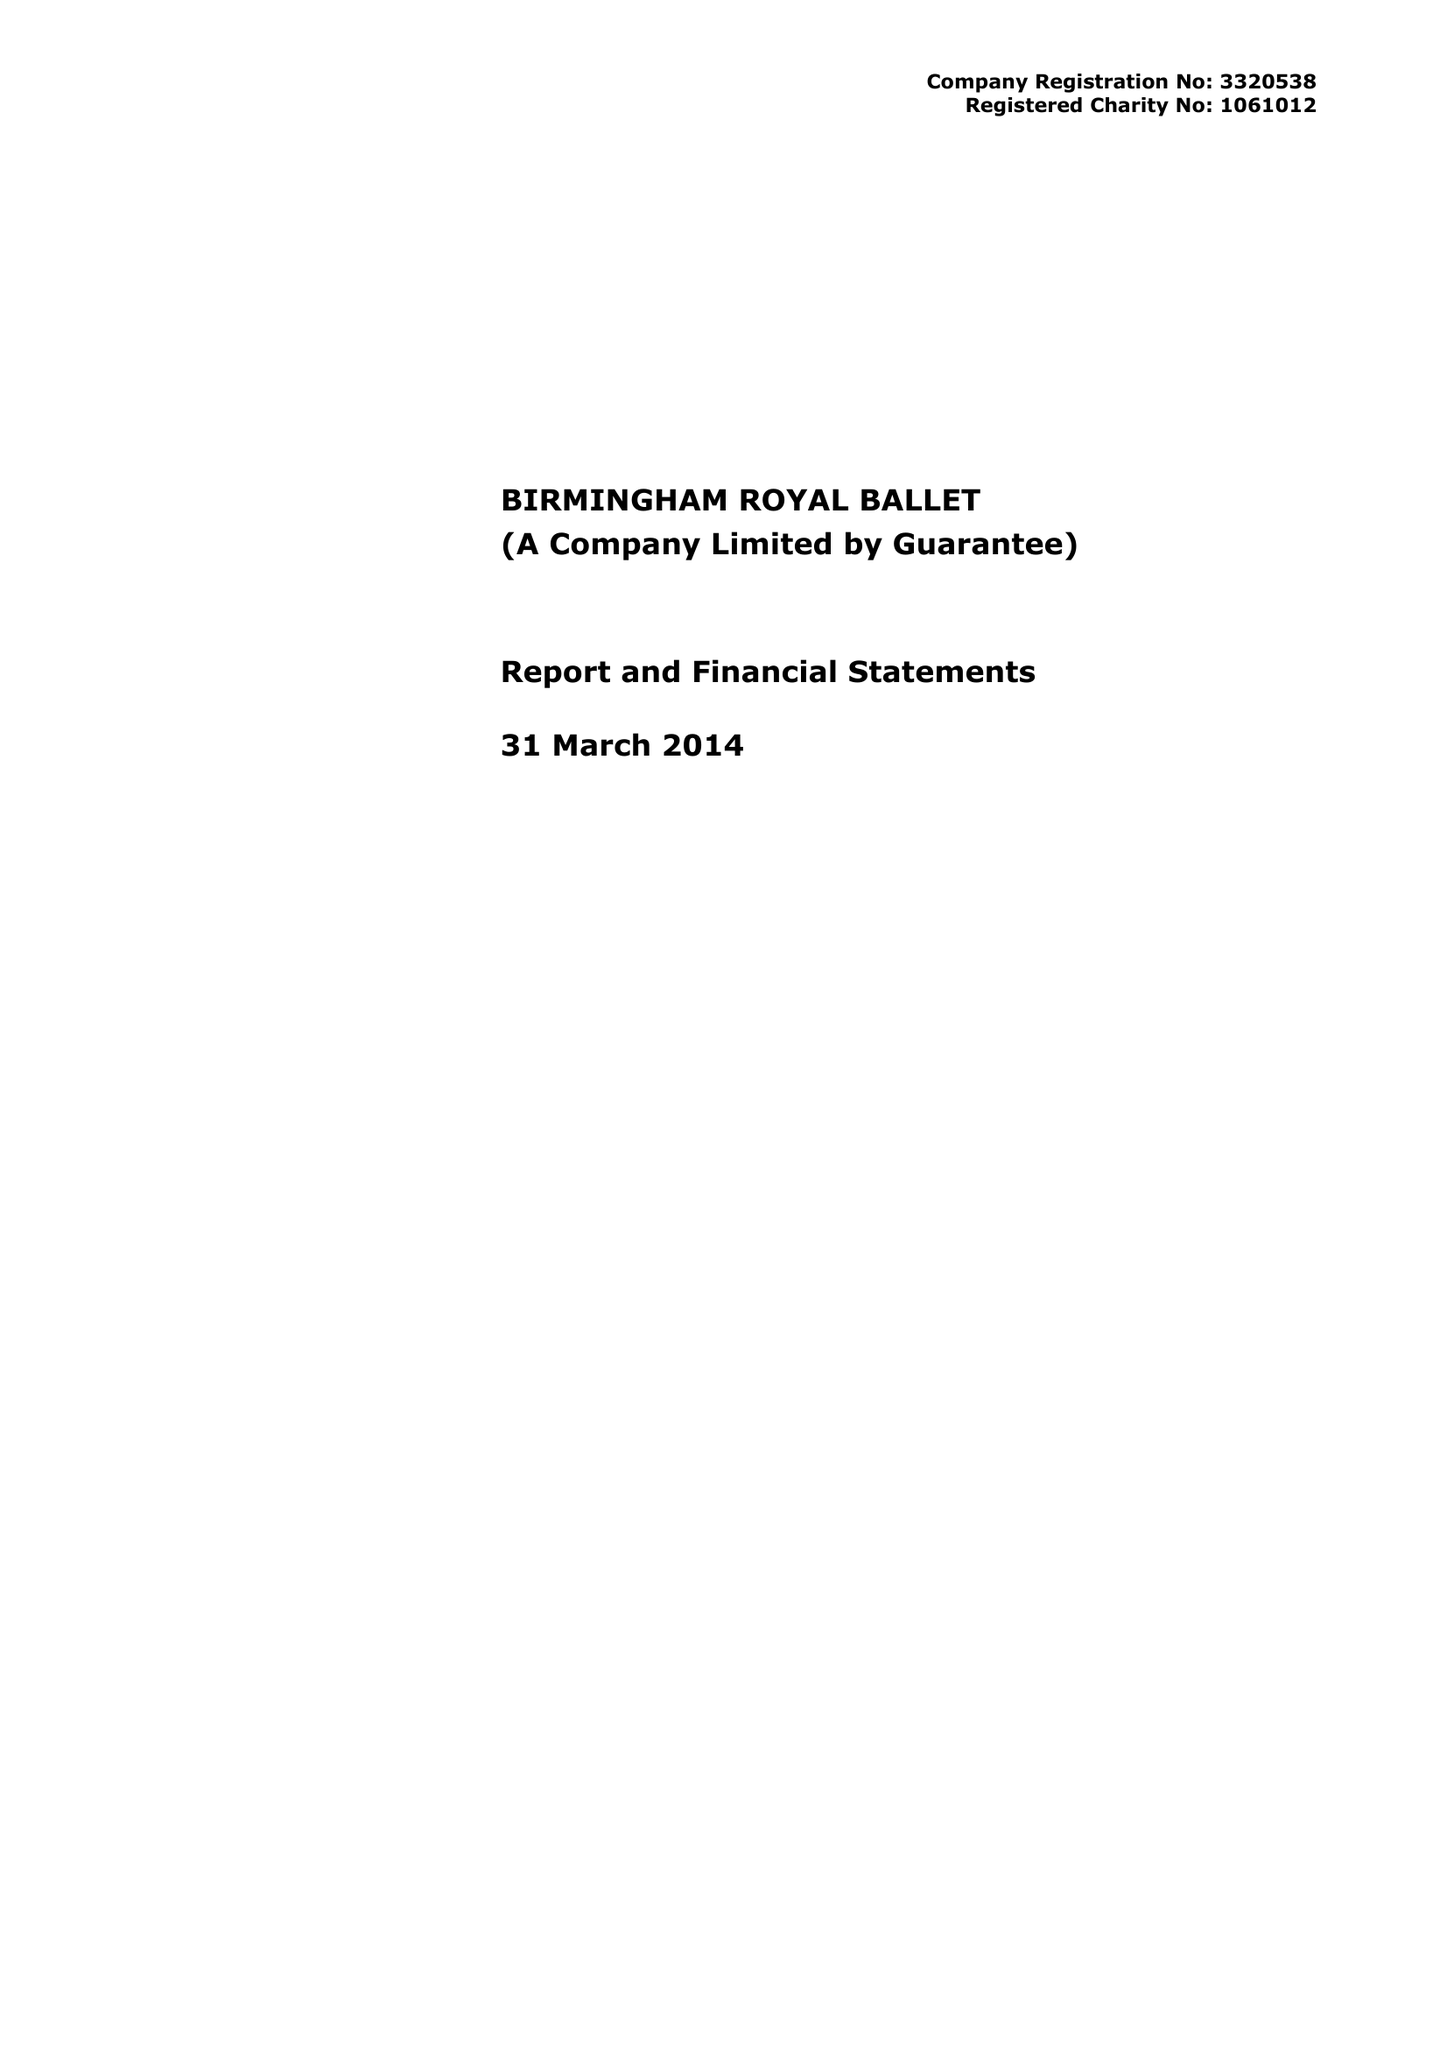What is the value for the income_annually_in_british_pounds?
Answer the question using a single word or phrase. 12812187.00 